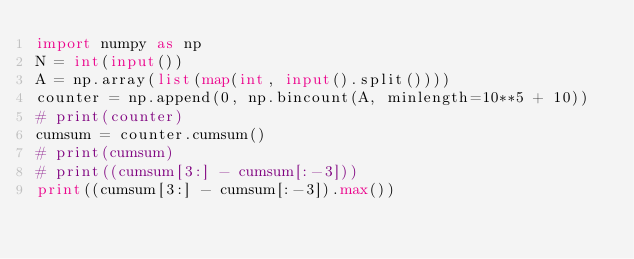<code> <loc_0><loc_0><loc_500><loc_500><_Python_>import numpy as np
N = int(input())
A = np.array(list(map(int, input().split())))
counter = np.append(0, np.bincount(A, minlength=10**5 + 10))
# print(counter)
cumsum = counter.cumsum()
# print(cumsum)
# print((cumsum[3:] - cumsum[:-3]))
print((cumsum[3:] - cumsum[:-3]).max())
</code> 